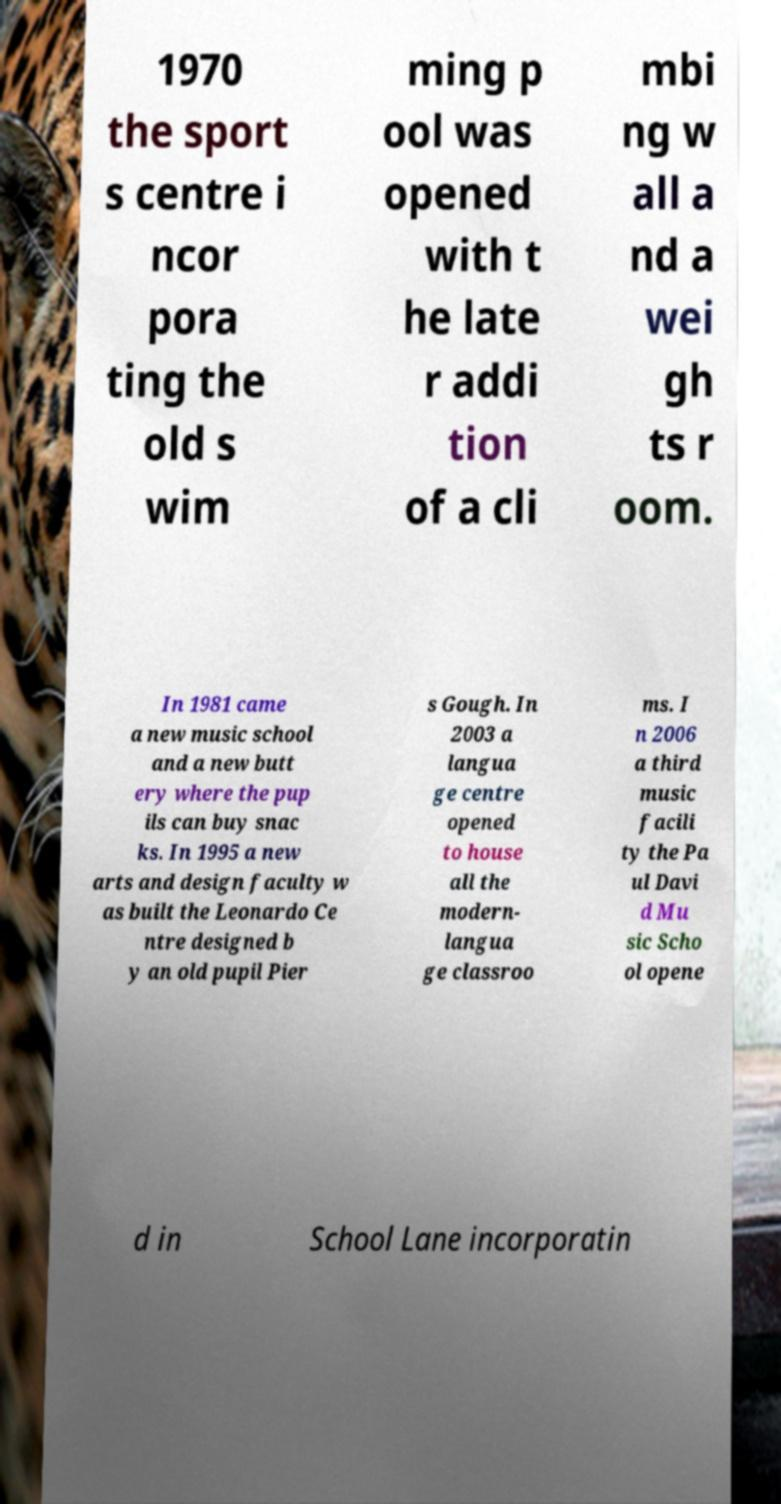Could you extract and type out the text from this image? 1970 the sport s centre i ncor pora ting the old s wim ming p ool was opened with t he late r addi tion of a cli mbi ng w all a nd a wei gh ts r oom. In 1981 came a new music school and a new butt ery where the pup ils can buy snac ks. In 1995 a new arts and design faculty w as built the Leonardo Ce ntre designed b y an old pupil Pier s Gough. In 2003 a langua ge centre opened to house all the modern- langua ge classroo ms. I n 2006 a third music facili ty the Pa ul Davi d Mu sic Scho ol opene d in School Lane incorporatin 